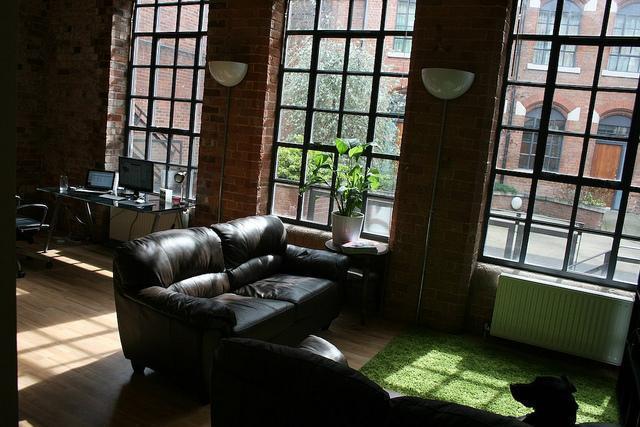How many white horses are pulling the carriage?
Give a very brief answer. 0. 